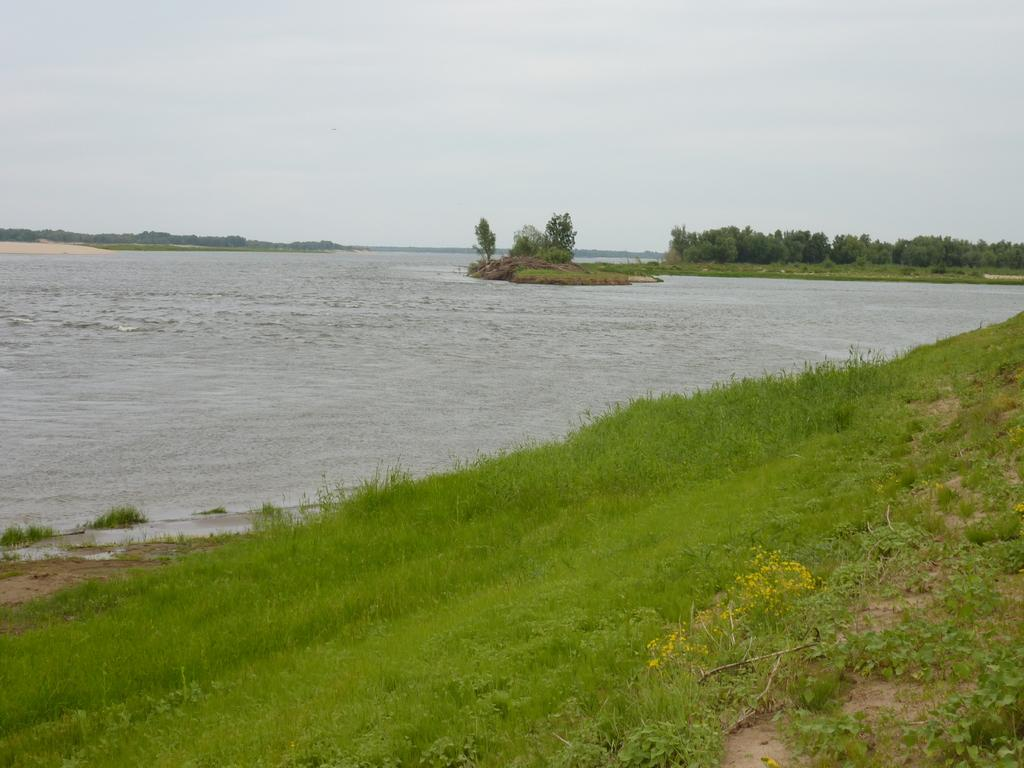What type of vegetation is at the bottom of the image? There is grass and plants at the bottom of the image. What is located in the middle of the image? There is water in the middle of the image. What can be seen in the background of the image? There are trees in the background of the image. What is visible at the top of the image? The sky is visible at the top of the image. How many geese are walking on the tramp in the image? There are no geese or tramp present in the image. What is the nationality of the nation depicted in the image? There is no nation depicted in the image; it features grass, plants, water, trees, and the sky. 